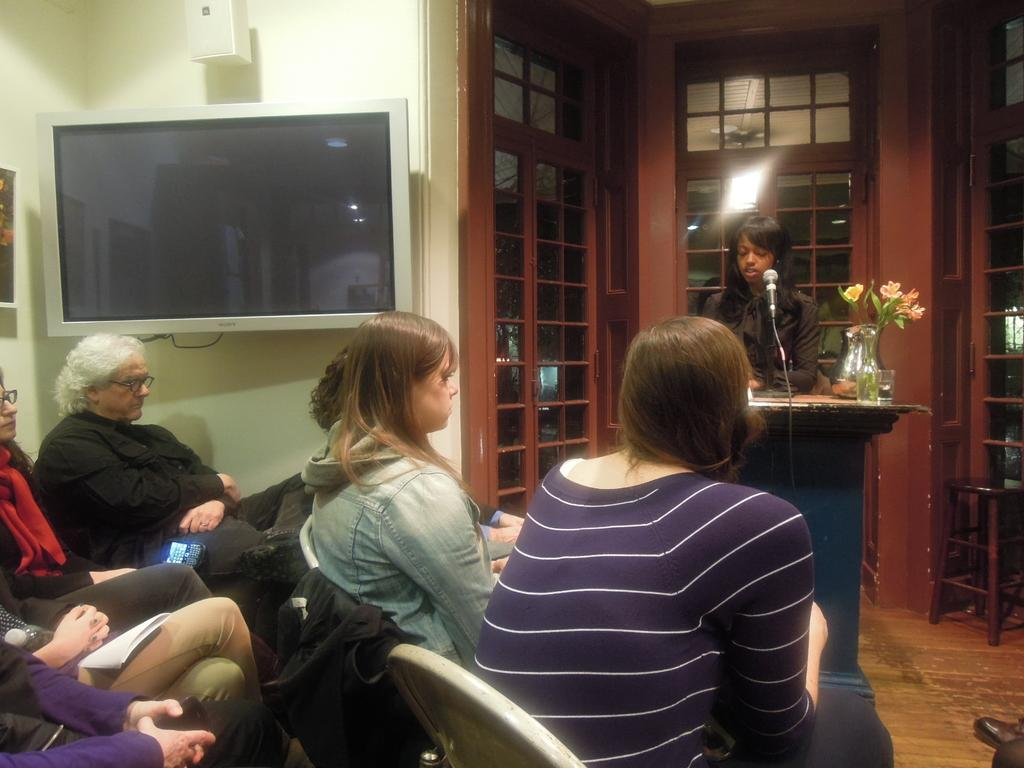What is the woman doing in the image? The woman is sitting on a chair in the image. What can be seen on the left side of the woman? There is a television on the left side of the woman. Who is in front of the woman? There is a girl in front of the woman. What is the girl holding in the image? The girl is holding a microphone. What sense is the girl using to communicate with the microphone in the image? The girl is using her sense of hearing to communicate with the microphone, as it is an audio device. However, the provided facts do not mention any specific sensory activity in the image. 